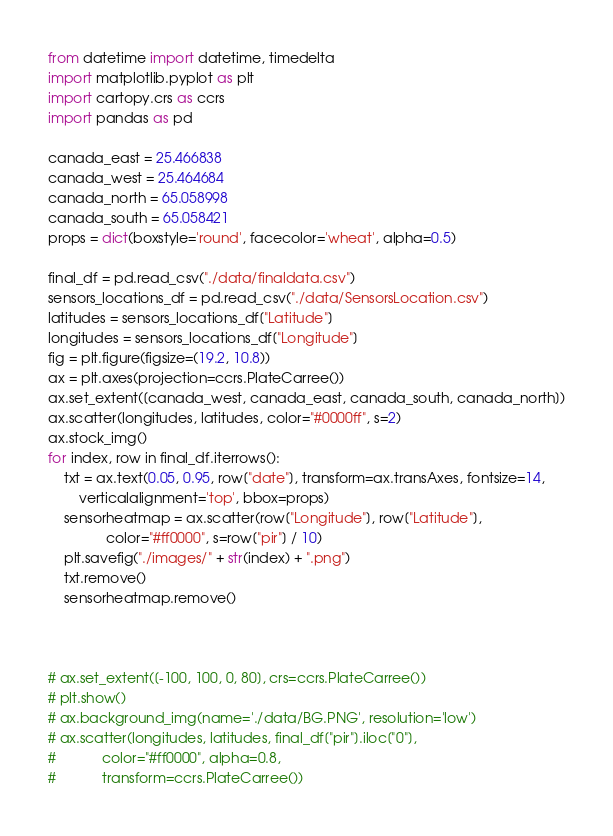Convert code to text. <code><loc_0><loc_0><loc_500><loc_500><_Python_>from datetime import datetime, timedelta
import matplotlib.pyplot as plt
import cartopy.crs as ccrs
import pandas as pd

canada_east = 25.466838
canada_west = 25.464684
canada_north = 65.058998
canada_south = 65.058421
props = dict(boxstyle='round', facecolor='wheat', alpha=0.5)

final_df = pd.read_csv("./data/finaldata.csv")
sensors_locations_df = pd.read_csv("./data/SensorsLocation.csv")
latitudes = sensors_locations_df["Latitude"]
longitudes = sensors_locations_df["Longitude"]
fig = plt.figure(figsize=(19.2, 10.8))
ax = plt.axes(projection=ccrs.PlateCarree())
ax.set_extent([canada_west, canada_east, canada_south, canada_north])
ax.scatter(longitudes, latitudes, color="#0000ff", s=2)
ax.stock_img()
for index, row in final_df.iterrows():
    txt = ax.text(0.05, 0.95, row["date"], transform=ax.transAxes, fontsize=14,
        verticalalignment='top', bbox=props)
    sensorheatmap = ax.scatter(row["Longitude"], row["Latitude"],
               color="#ff0000", s=row["pir"] / 10)
    plt.savefig("./images/" + str(index) + ".png")
    txt.remove()
    sensorheatmap.remove()



# ax.set_extent([-100, 100, 0, 80], crs=ccrs.PlateCarree())
# plt.show()
# ax.background_img(name='./data/BG.PNG', resolution='low')
# ax.scatter(longitudes, latitudes, final_df["pir"].iloc["0"],
#            color="#ff0000", alpha=0.8,
#            transform=ccrs.PlateCarree())
</code> 